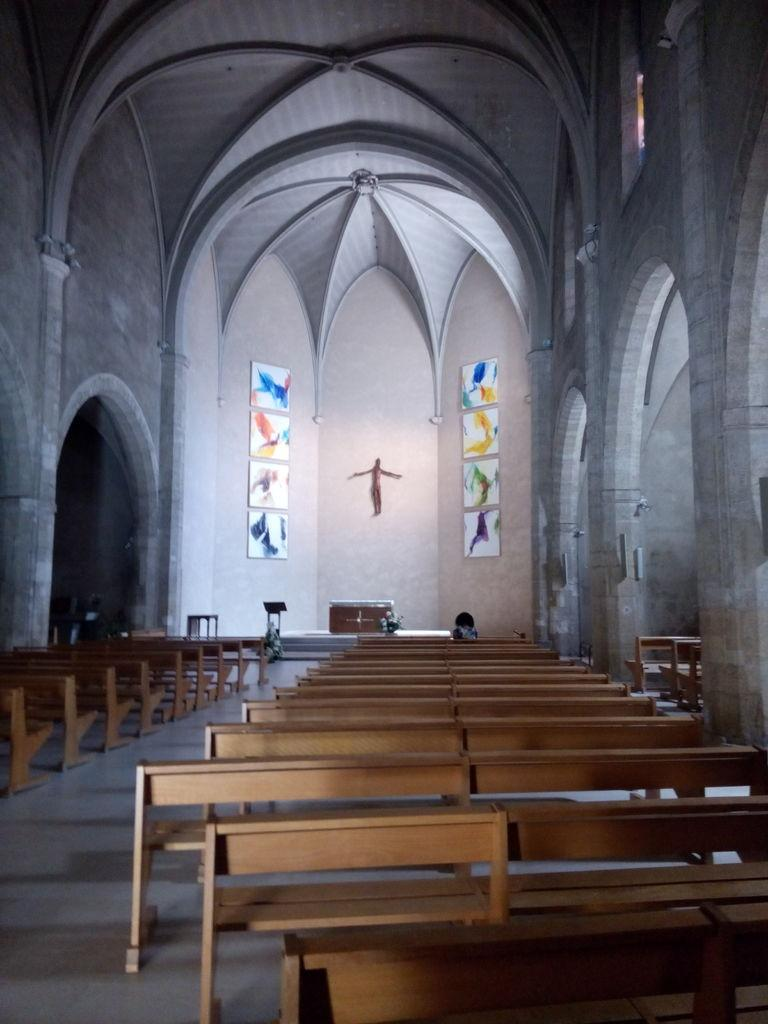What type of building is shown in the image? The image shows the inside of a church. What type of seating is available in the church? There are many benches in the image. Are there any decorations or objects on the walls in the church? Yes, there are objects on the wall in the image. How many legs can be seen on the people in the image? There are no people visible in the image, so it is impossible to determine the number of legs. --- Facts: 1. There is a person holding a book in the image. 2. The person is sitting on a chair. 3. The chair has a patterned fabric. 4. There is a table next to the chair. 5. The table has a lamp on it. Absurd Topics: elephant, dance, ocean Conversation: What is the person in the image holding? The person is holding a book in the image. What is the person sitting on? The person is sitting on a chair in the image. Can you describe the chair's appearance? The chair has a patterned fabric. What is located next to the chair? There is a table next to the chair in the image. What is on the table? The table has a lamp on it. Reasoning: Let's think step by step in order to produce the conversation. We start by identifying the main subject of the image, which is the person holding a book. Then, we describe the person's position by mentioning that they are sitting on a chair. Next, we provide details about the chair's appearance, noting the patterned fabric. Finally, we mention the presence of a table next to the chair and describe the object on the table, which is a lamp. Absurd Question/Answer: Can you see any elephants in the image? No, there are no elephants present in the image. Is the person in the image dancing? No, the person is sitting and holding a book, not dancing. 